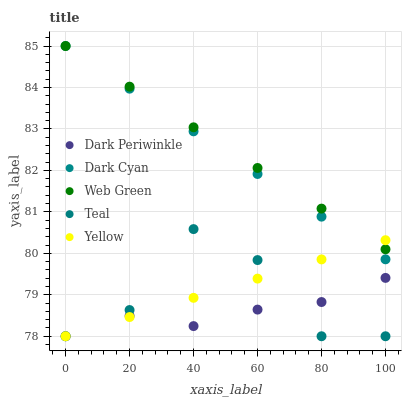Does Dark Periwinkle have the minimum area under the curve?
Answer yes or no. Yes. Does Web Green have the maximum area under the curve?
Answer yes or no. Yes. Does Yellow have the minimum area under the curve?
Answer yes or no. No. Does Yellow have the maximum area under the curve?
Answer yes or no. No. Is Yellow the smoothest?
Answer yes or no. Yes. Is Teal the roughest?
Answer yes or no. Yes. Is Teal the smoothest?
Answer yes or no. No. Is Yellow the roughest?
Answer yes or no. No. Does Yellow have the lowest value?
Answer yes or no. Yes. Does Web Green have the lowest value?
Answer yes or no. No. Does Web Green have the highest value?
Answer yes or no. Yes. Does Yellow have the highest value?
Answer yes or no. No. Is Dark Periwinkle less than Dark Cyan?
Answer yes or no. Yes. Is Web Green greater than Teal?
Answer yes or no. Yes. Does Dark Periwinkle intersect Yellow?
Answer yes or no. Yes. Is Dark Periwinkle less than Yellow?
Answer yes or no. No. Is Dark Periwinkle greater than Yellow?
Answer yes or no. No. Does Dark Periwinkle intersect Dark Cyan?
Answer yes or no. No. 